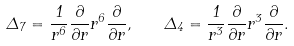Convert formula to latex. <formula><loc_0><loc_0><loc_500><loc_500>\Delta _ { 7 } = \frac { 1 } { r ^ { 6 } } \frac { \partial } { \partial r } r ^ { 6 } \frac { \partial } { \partial r } , \quad \Delta _ { 4 } = \frac { 1 } { r ^ { 3 } } \frac { \partial } { \partial r } r ^ { 3 } \frac { \partial } { \partial r } .</formula> 